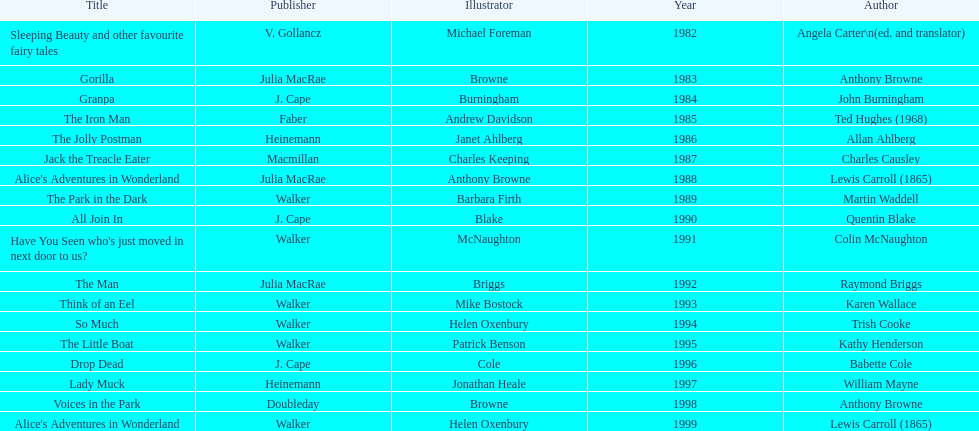Which designer was in charge of the last award-winning piece? Helen Oxenbury. 